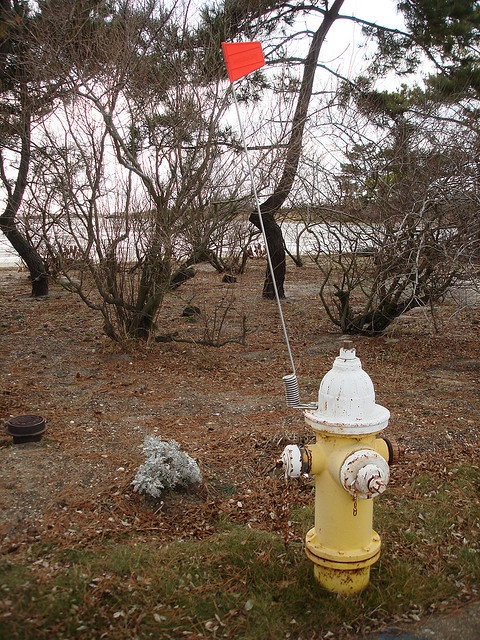Describe the objects in this image and their specific colors. I can see a fire hydrant in black, tan, lightgray, and olive tones in this image. 